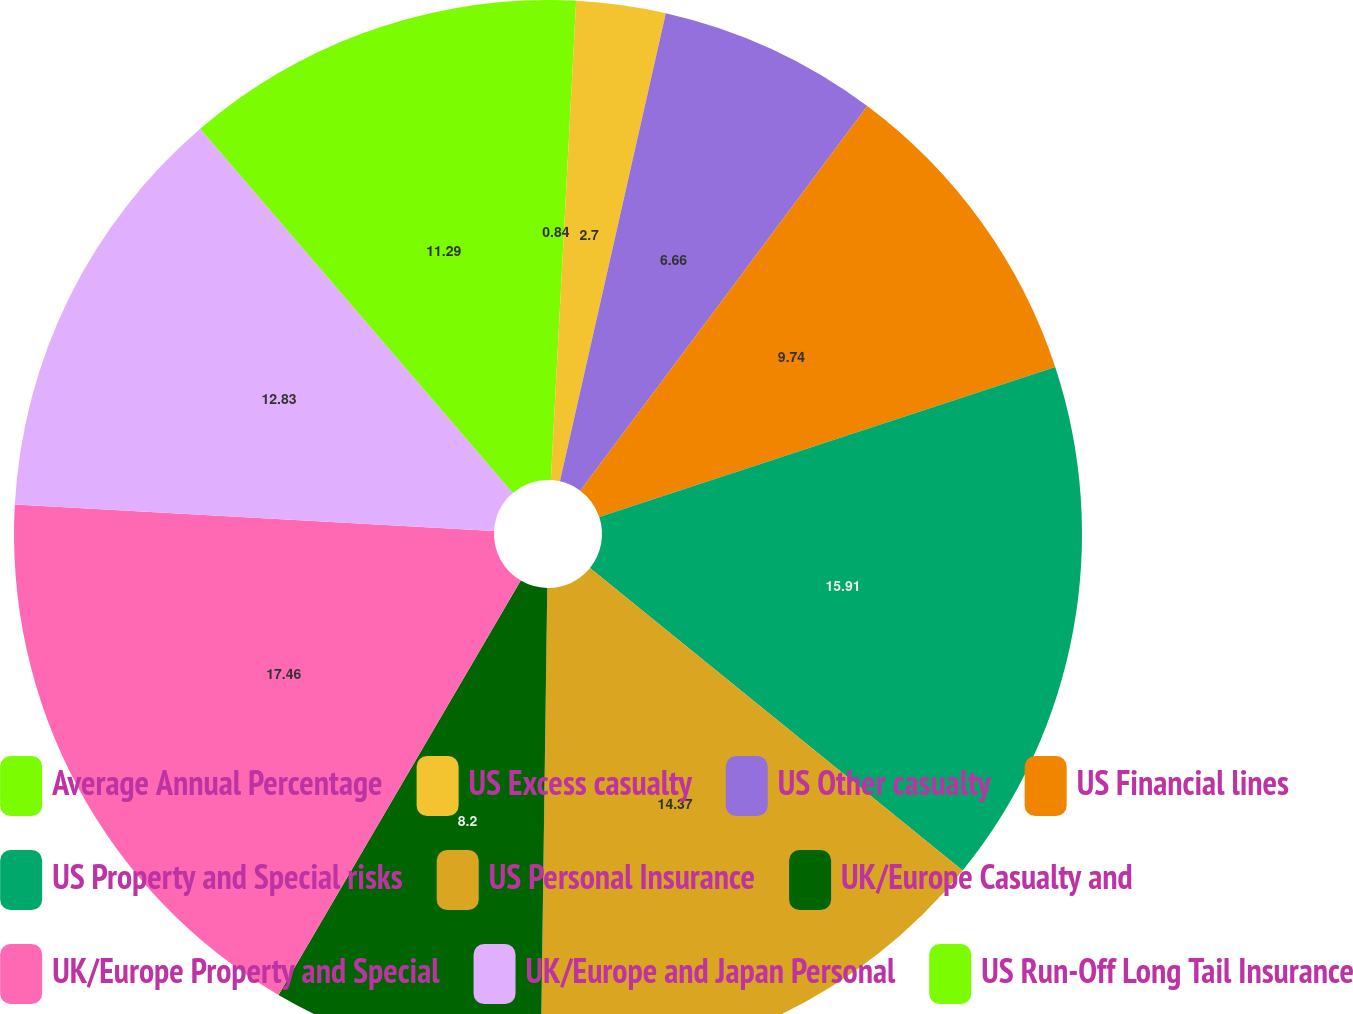Convert chart to OTSL. <chart><loc_0><loc_0><loc_500><loc_500><pie_chart><fcel>Average Annual Percentage<fcel>US Excess casualty<fcel>US Other casualty<fcel>US Financial lines<fcel>US Property and Special risks<fcel>US Personal Insurance<fcel>UK/Europe Casualty and<fcel>UK/Europe Property and Special<fcel>UK/Europe and Japan Personal<fcel>US Run-Off Long Tail Insurance<nl><fcel>0.84%<fcel>2.7%<fcel>6.66%<fcel>9.74%<fcel>15.91%<fcel>14.37%<fcel>8.2%<fcel>17.46%<fcel>12.83%<fcel>11.29%<nl></chart> 